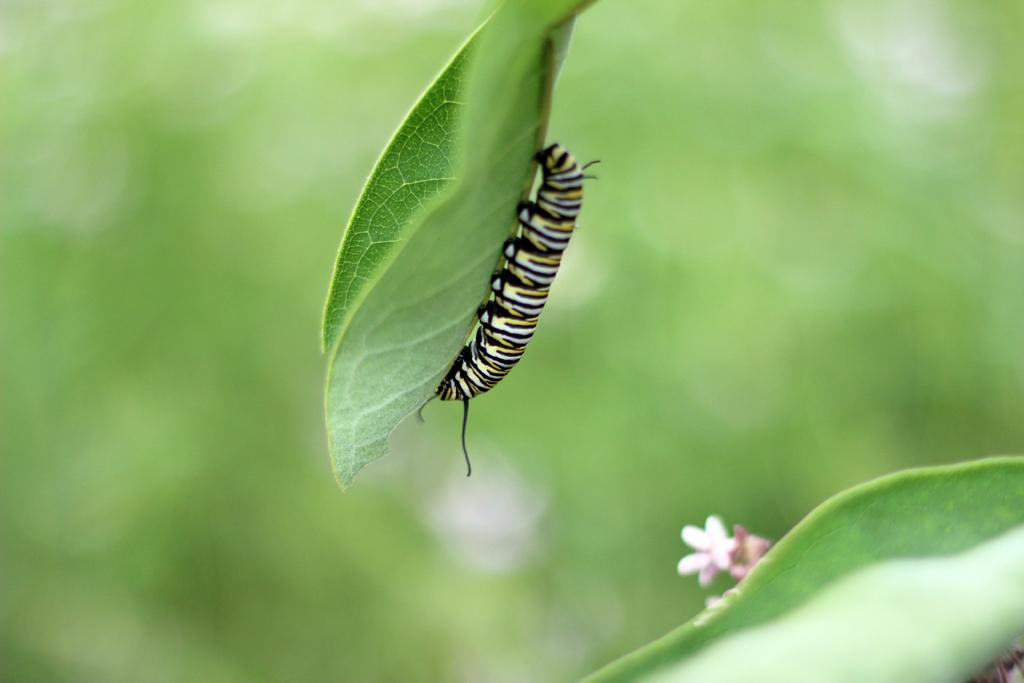What is present on the leaf in the image? There is a caterpillar on the leaf in the image. What colors can be seen on the caterpillar? The caterpillar has black, white, and yellow colors. What is located at the bottom of the image? There is a leaf and a pink flower at the bottom of the image. What color is the background of the image? The background of the image is green. What type of paint is the father using to destroy the caterpillar in the image? There is no father or paint present in the image, and the caterpillar is not being destroyed. 